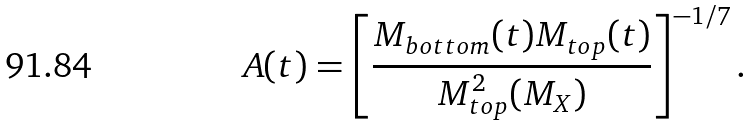Convert formula to latex. <formula><loc_0><loc_0><loc_500><loc_500>A ( t ) = \left [ \frac { M _ { b o t t o m } ( t ) M _ { t o p } ( t ) } { M _ { t o p } ^ { 2 } ( M _ { X } ) } \right ] ^ { - 1 / 7 } .</formula> 